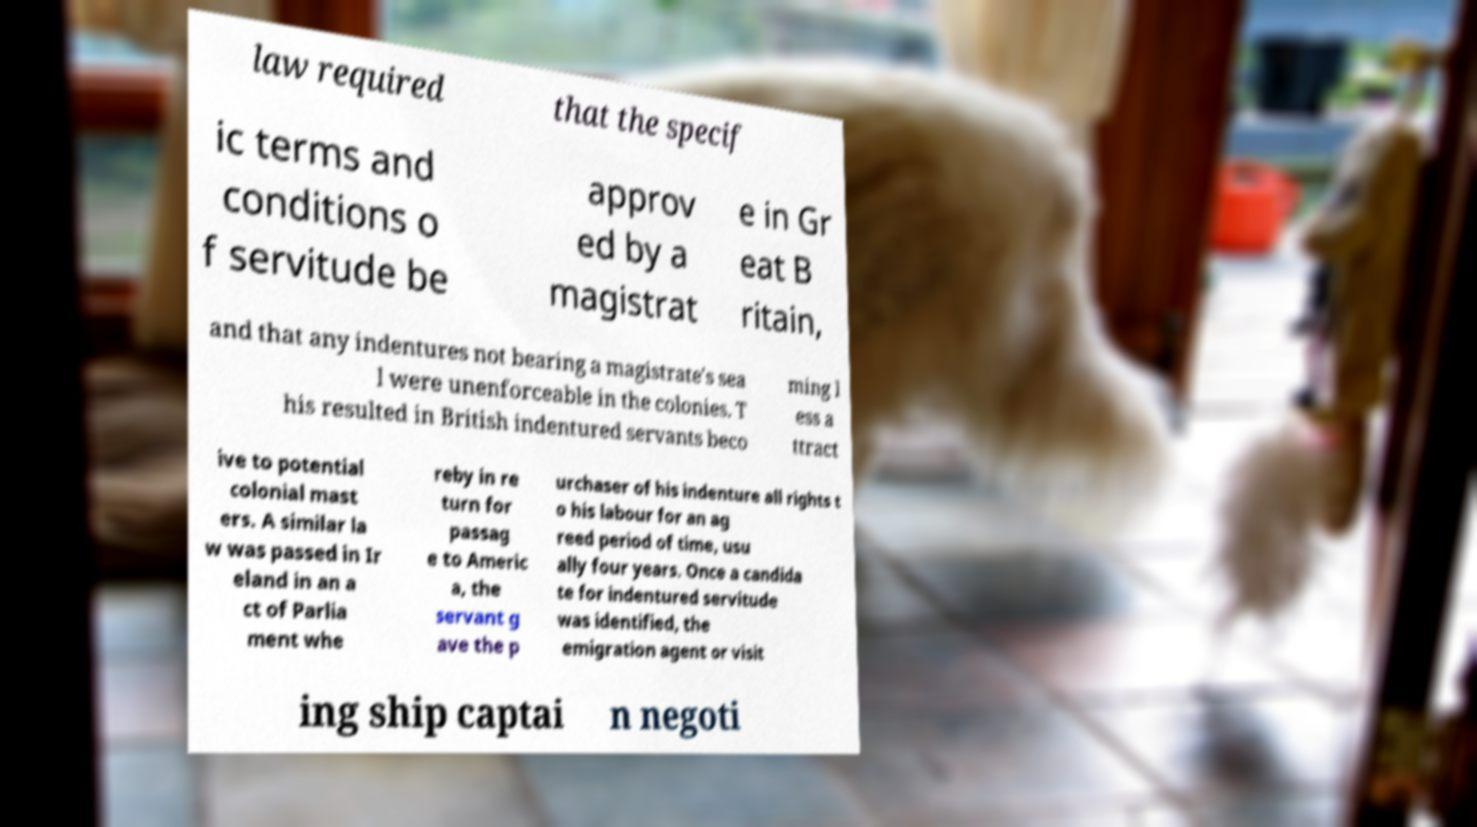Could you extract and type out the text from this image? law required that the specif ic terms and conditions o f servitude be approv ed by a magistrat e in Gr eat B ritain, and that any indentures not bearing a magistrate's sea l were unenforceable in the colonies. T his resulted in British indentured servants beco ming l ess a ttract ive to potential colonial mast ers. A similar la w was passed in Ir eland in an a ct of Parlia ment whe reby in re turn for passag e to Americ a, the servant g ave the p urchaser of his indenture all rights t o his labour for an ag reed period of time, usu ally four years. Once a candida te for indentured servitude was identified, the emigration agent or visit ing ship captai n negoti 